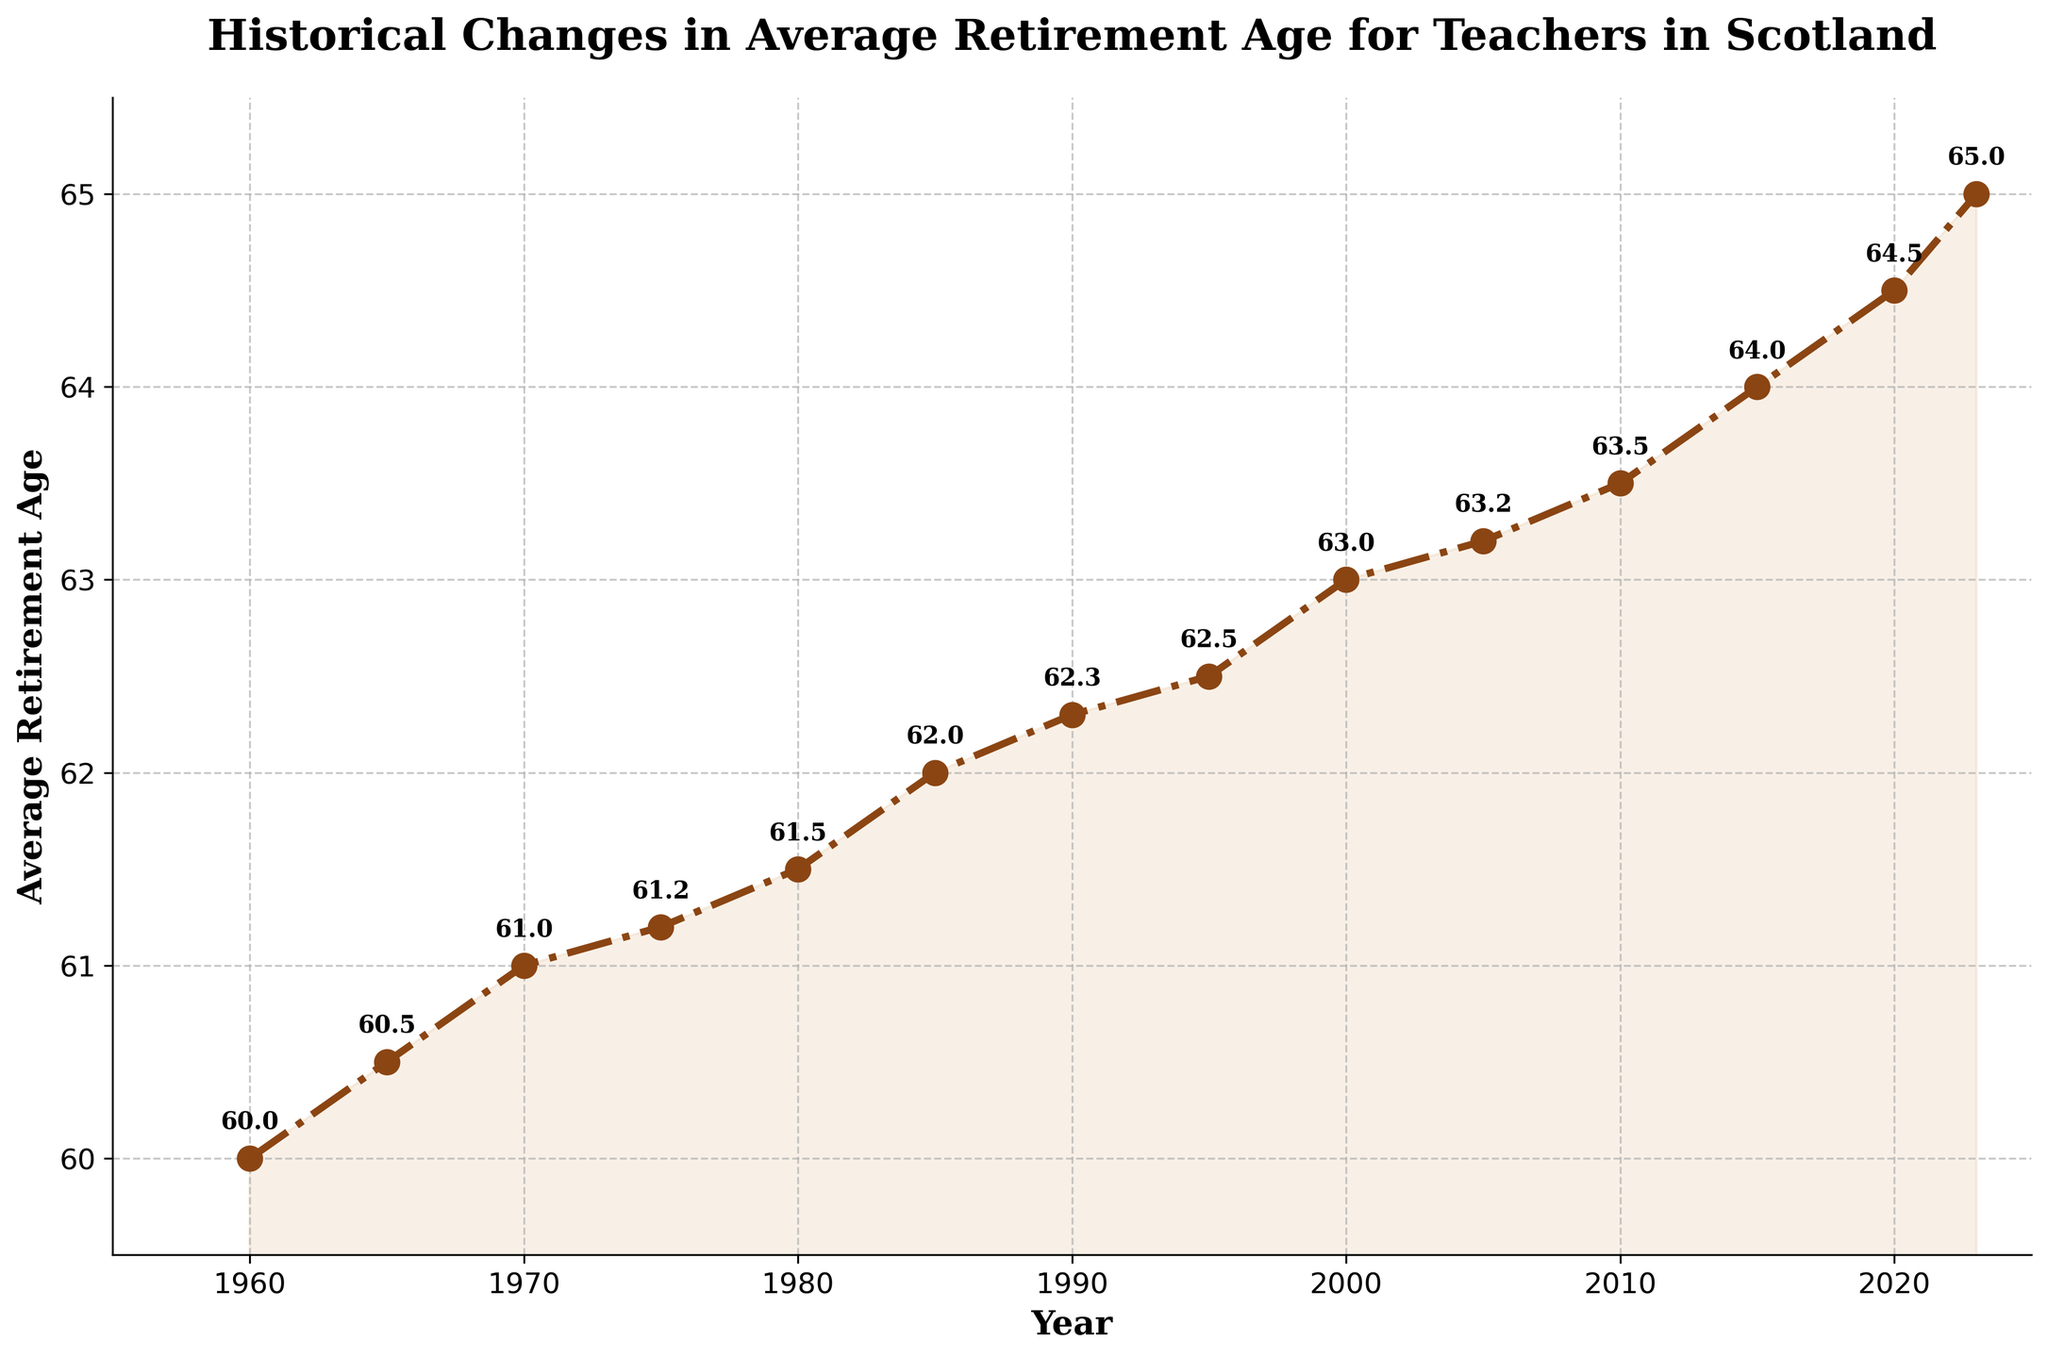What is the average retirement age for teachers in Scotland in 1980? Locate the data point for the year 1980 on the x-axis and read the corresponding y-axis value for the average retirement age.
Answer: 61.5 How much has the average retirement age increased from 1960 to 2023? Find the average retirement age in 1960 (60) and in 2023 (65). Calculate the difference: 65 - 60 = 5.
Answer: 5 Which year shows the smallest increase in the average retirement age from the previous year? Compare the difference in average retirement age between each consecutive pair of points. The smallest increase is between 1970 (61) and 1975 (61.2), which is 0.2.
Answer: 1975 Between which two decades did the average retirement age increase the most? Calculate the increase for each decade: 1960-1970 (61-60=1), 1970-1980 (61.5-61=0.5), 1980-1990 (62.3-61.5=0.8), 1990-2000 (63-62.3=0.7), 2000-2010 (63.5-63=0.5), 2010-2020 (64.5-63.5=1). The largest increase is from 1960-1970.
Answer: 1960-1970 What is the overall trend in the average retirement age from 1960 to 2023? Examine the general direction of the line on the graph. If the line moves upwards from left to right, it indicates an increasing trend.
Answer: Increasing Compare the average retirement ages in 1965 and 1985. Which one is higher? Find the data points for 1965 (60.5) and 1985 (62) and compare them. The value in 1985 is higher.
Answer: 1985 How does the average retirement age in 1995 compare to that in 2020? Locate the data points for 1995 (62.5) and 2020 (64.5) and compare them. The value in 2020 is higher.
Answer: 2020 What is the visual pattern of the average retirement age line from 1960 to 2023? Observe the overall shape and movement of the line. The line steadily rises, with slight increases each year.
Answer: Steadily rising What is the average retirement age for teachers in Scotland in the year 2000? Look at the data point corresponding to the year 2000 on the x-axis and read the value on the y-axis.
Answer: 63 How many years did it take for the average retirement age to increase by one year from 1965 (60.5) to 1975 (61.5)? Identify the given years and their corresponding average retirement ages, then calculate how many years it took for the difference of 1 year. From 1965 (60.5) to 1975 (61.5), it took 10 years.
Answer: 10 